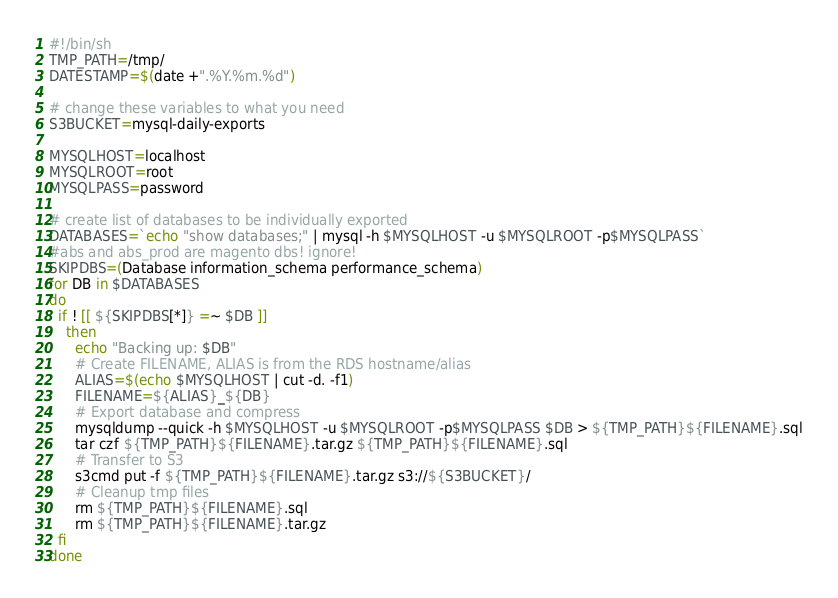Convert code to text. <code><loc_0><loc_0><loc_500><loc_500><_Bash_>#!/bin/sh
TMP_PATH=/tmp/
DATESTAMP=$(date +".%Y.%m.%d")

# change these variables to what you need
S3BUCKET=mysql-daily-exports

MYSQLHOST=localhost
MYSQLROOT=root
MYSQLPASS=password

# create list of databases to be individually exported
DATABASES=`echo "show databases;" | mysql -h $MYSQLHOST -u $MYSQLROOT -p$MYSQLPASS`
#abs and abs_prod are magento dbs! ignore!
SKIPDBS=(Database information_schema performance_schema)
for DB in $DATABASES
do
  if ! [[ ${SKIPDBS[*]} =~ $DB ]]
    then
      echo "Backing up: $DB"
      # Create FILENAME, ALIAS is from the RDS hostname/alias
      ALIAS=$(echo $MYSQLHOST | cut -d. -f1)
      FILENAME=${ALIAS}_${DB}
      # Export database and compress
      mysqldump --quick -h $MYSQLHOST -u $MYSQLROOT -p$MYSQLPASS $DB > ${TMP_PATH}${FILENAME}.sql
      tar czf ${TMP_PATH}${FILENAME}.tar.gz ${TMP_PATH}${FILENAME}.sql
      # Transfer to S3
      s3cmd put -f ${TMP_PATH}${FILENAME}.tar.gz s3://${S3BUCKET}/
      # Cleanup tmp files
      rm ${TMP_PATH}${FILENAME}.sql
      rm ${TMP_PATH}${FILENAME}.tar.gz
  fi
done</code> 